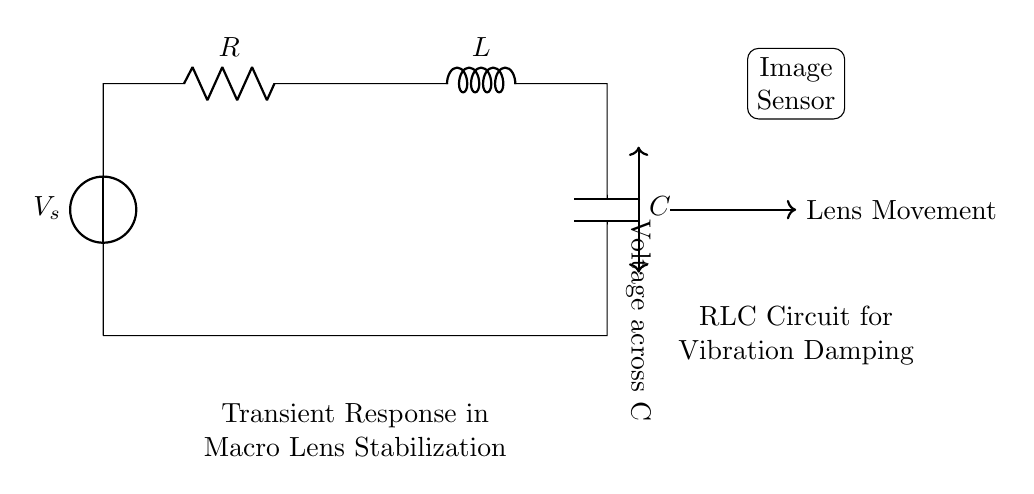What are the components of the circuit? The circuit consists of a voltage source, resistor, inductor, and capacitor. These are the four main components depicted in the diagram.
Answer: voltage source, resistor, inductor, capacitor What does the voltage source represent? The voltage source, labeled as \( V_s \), provides the electrical energy needed to initiate the transient response in the RLC circuit.
Answer: electrical energy What is the function of the resistor in this circuit? The resistor dissipates energy in the form of heat and affects the damping in the circuit, influencing the transient response.
Answer: energy dissipation What is connected to the inductor? The inductor is connected directly to the resistor and the capacitor, forming an RLC series circuit which is important for its transient behavior.
Answer: resistor and capacitor What is the purpose of this RLC circuit in the context of image stabilization? The RLC circuit is used for vibration damping, which stabilizes the lens movement in the macro lens image stabilization system.
Answer: vibration damping What is the expected transient response of this circuit? The circuit exhibits an underdamped response, characterized by oscillations that gradually decrease, which is desired for smooth image stabilization.
Answer: underdamped response What type of damping does this circuit aim for? The circuit aims for underdamped damping, providing a balance between responsiveness and stability during lens movement.
Answer: underdamped 